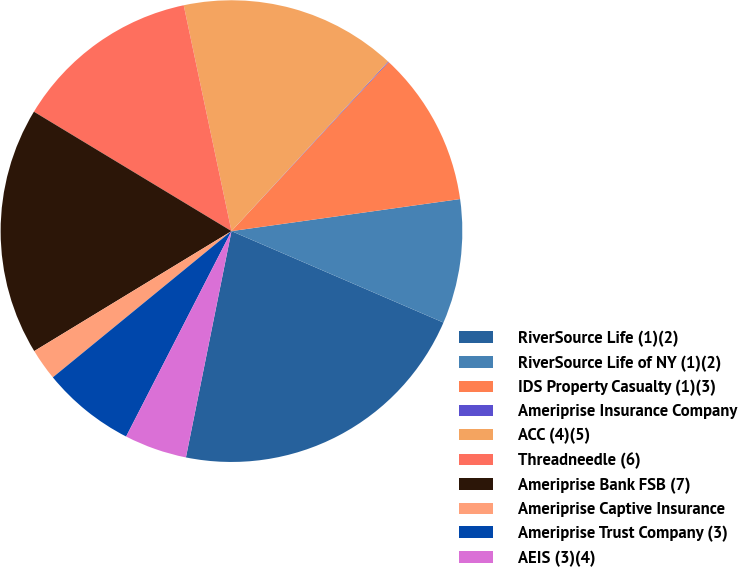Convert chart to OTSL. <chart><loc_0><loc_0><loc_500><loc_500><pie_chart><fcel>RiverSource Life (1)(2)<fcel>RiverSource Life of NY (1)(2)<fcel>IDS Property Casualty (1)(3)<fcel>Ameriprise Insurance Company<fcel>ACC (4)(5)<fcel>Threadneedle (6)<fcel>Ameriprise Bank FSB (7)<fcel>Ameriprise Captive Insurance<fcel>Ameriprise Trust Company (3)<fcel>AEIS (3)(4)<nl><fcel>21.68%<fcel>8.7%<fcel>10.86%<fcel>0.05%<fcel>15.19%<fcel>13.03%<fcel>17.35%<fcel>2.22%<fcel>6.54%<fcel>4.38%<nl></chart> 